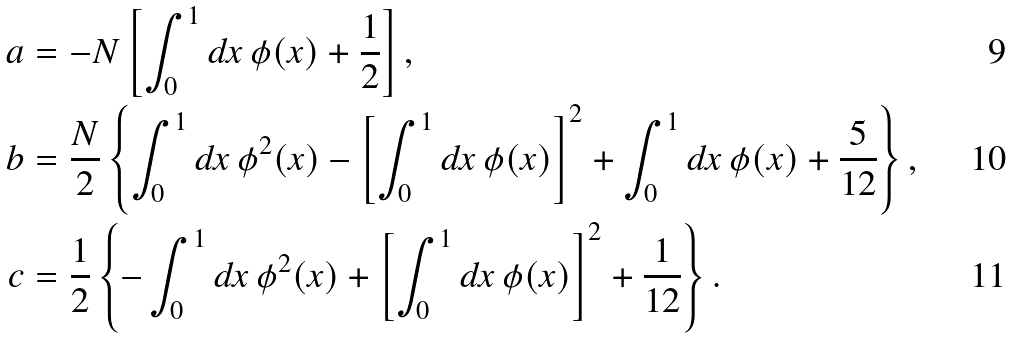Convert formula to latex. <formula><loc_0><loc_0><loc_500><loc_500>a & = - N \left [ \int _ { 0 } ^ { 1 } d x \, \phi ( x ) + \frac { 1 } { 2 } \right ] , \\ b & = \frac { N } { 2 } \left \{ \int _ { 0 } ^ { 1 } d x \, \phi ^ { 2 } ( x ) - \left [ \int _ { 0 } ^ { 1 } d x \, \phi ( x ) \right ] ^ { 2 } + \int _ { 0 } ^ { 1 } d x \, \phi ( x ) + \frac { 5 } { 1 2 } \right \} , \\ c & = \frac { 1 } { 2 } \left \{ - \int _ { 0 } ^ { 1 } d x \, \phi ^ { 2 } ( x ) + \left [ \int _ { 0 } ^ { 1 } d x \, \phi ( x ) \right ] ^ { 2 } + \frac { 1 } { 1 2 } \right \} .</formula> 